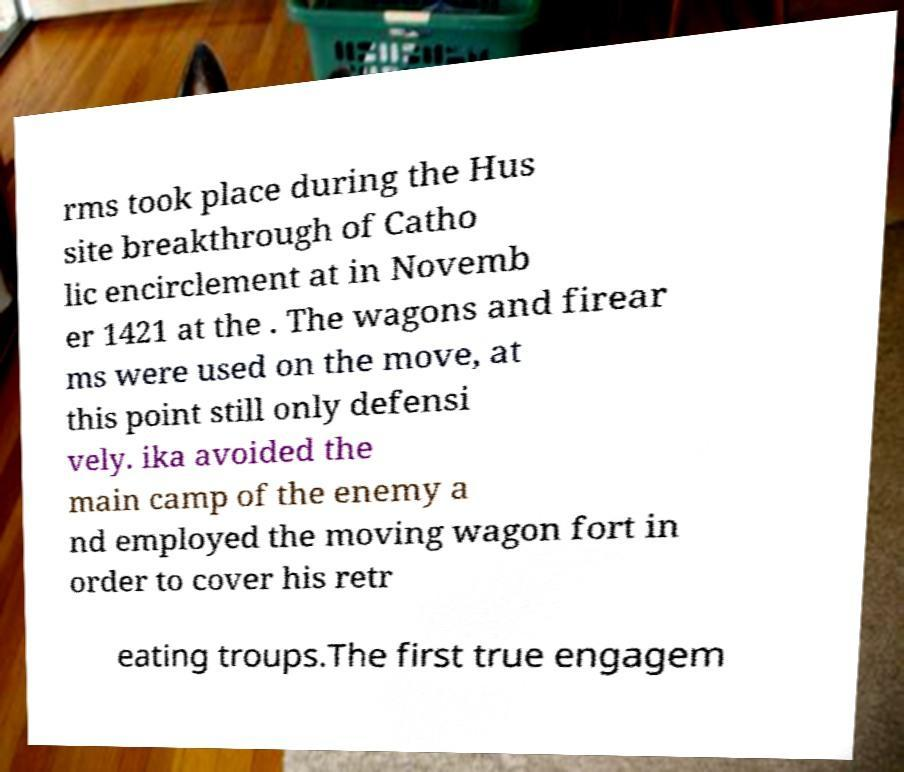Could you extract and type out the text from this image? rms took place during the Hus site breakthrough of Catho lic encirclement at in Novemb er 1421 at the . The wagons and firear ms were used on the move, at this point still only defensi vely. ika avoided the main camp of the enemy a nd employed the moving wagon fort in order to cover his retr eating troups.The first true engagem 